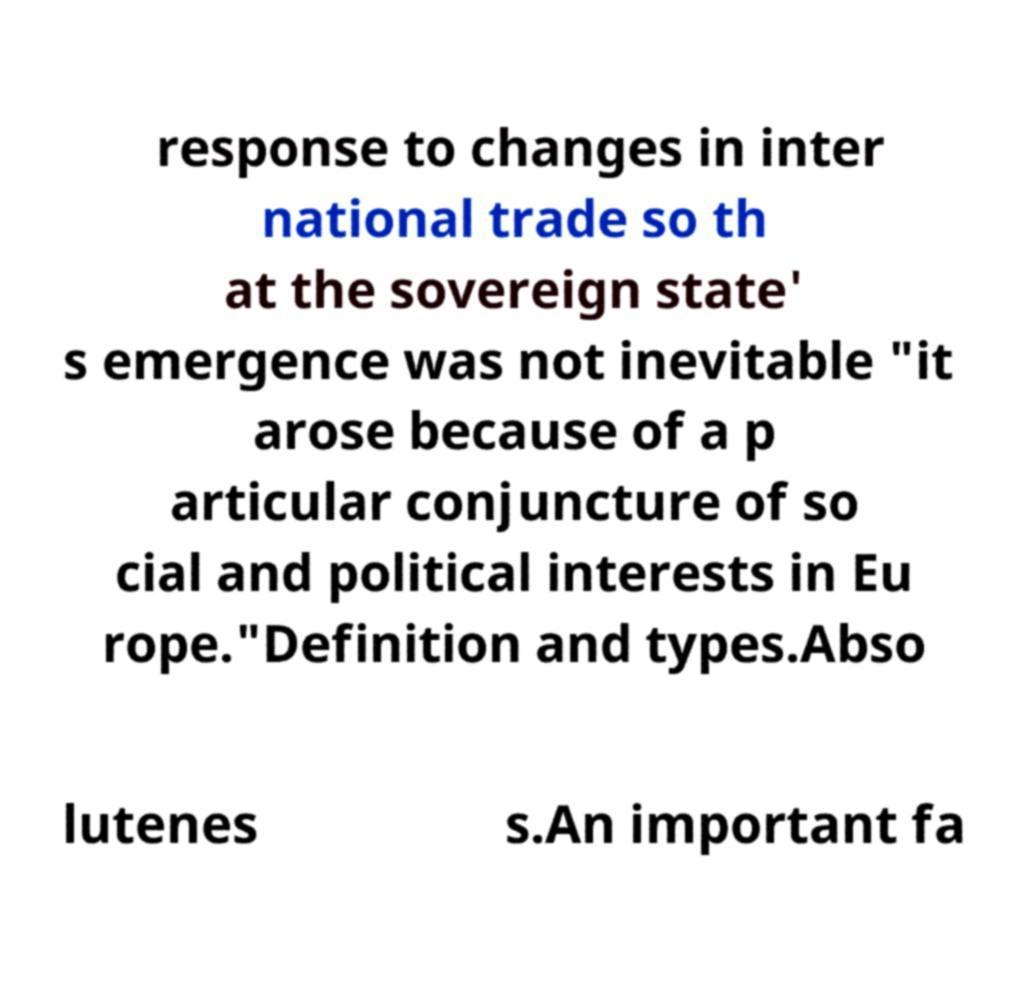Please identify and transcribe the text found in this image. response to changes in inter national trade so th at the sovereign state' s emergence was not inevitable "it arose because of a p articular conjuncture of so cial and political interests in Eu rope."Definition and types.Abso lutenes s.An important fa 